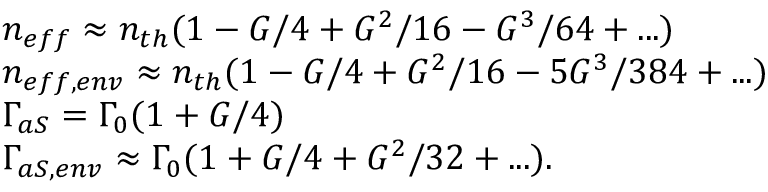<formula> <loc_0><loc_0><loc_500><loc_500>\begin{array} { r l } & { \, n _ { e f f } \approx n _ { t h } ( 1 - G / 4 + G ^ { 2 } / 1 6 - G ^ { 3 } / 6 4 + \dots ) } \\ & { \, n _ { e f f , e n v } \approx n _ { t h } ( 1 - G / 4 + G ^ { 2 } / 1 6 - 5 G ^ { 3 } / 3 8 4 + \dots ) } \\ & { \, \Gamma _ { a S } = \Gamma _ { 0 } ( 1 + G / 4 ) } \\ & { \, \Gamma _ { a S , e n v } \approx \Gamma _ { 0 } ( 1 + G / 4 + G ^ { 2 } / 3 2 + \dots ) . } \end{array}</formula> 